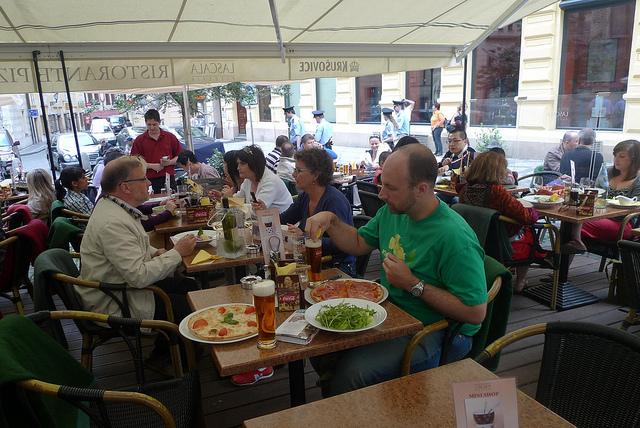What are the people at the nearest table eating?
Short answer required. Pizza. Are the patrons eating indoors or outdoors?
Answer briefly. Outdoors. What is the man in the green shirt drinking?
Quick response, please. Beer. Are they in a mess hall?
Be succinct. No. What are they drinking?
Short answer required. Beer. 